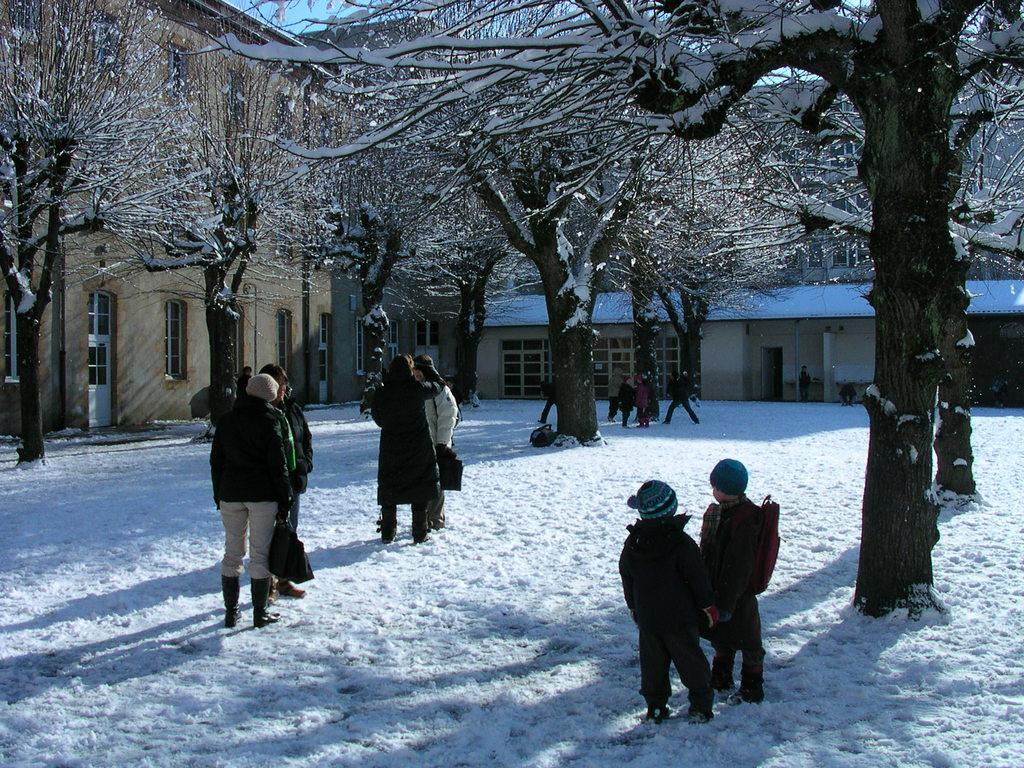How many people are in the image? There is a group of people in the image, but the exact number is not specified. What is the setting of the image? The people are standing in the snow. What are some people holding in the image? Some people are holding bags. What can be seen in the background of the image? There are trees and houses in the background of the image. What type of bait is being used by the people in the image? There is no mention of bait or fishing in the image; the people are standing in the snow and holding bags. How many cakes are visible in the image? There is no mention of cakes in the image; the focus is on the group of people standing in the snow and holding bags. 